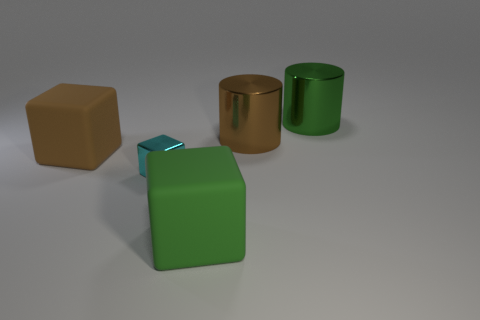Describe the surface on which the objects are placed. The objects are sitting on a smooth, neutral-toned surface that doesn't reflect much light, suggesting it may have a matte finish. There aren't any discernible textures or patterns, and it complements the simplicity of the objects' presentation. 